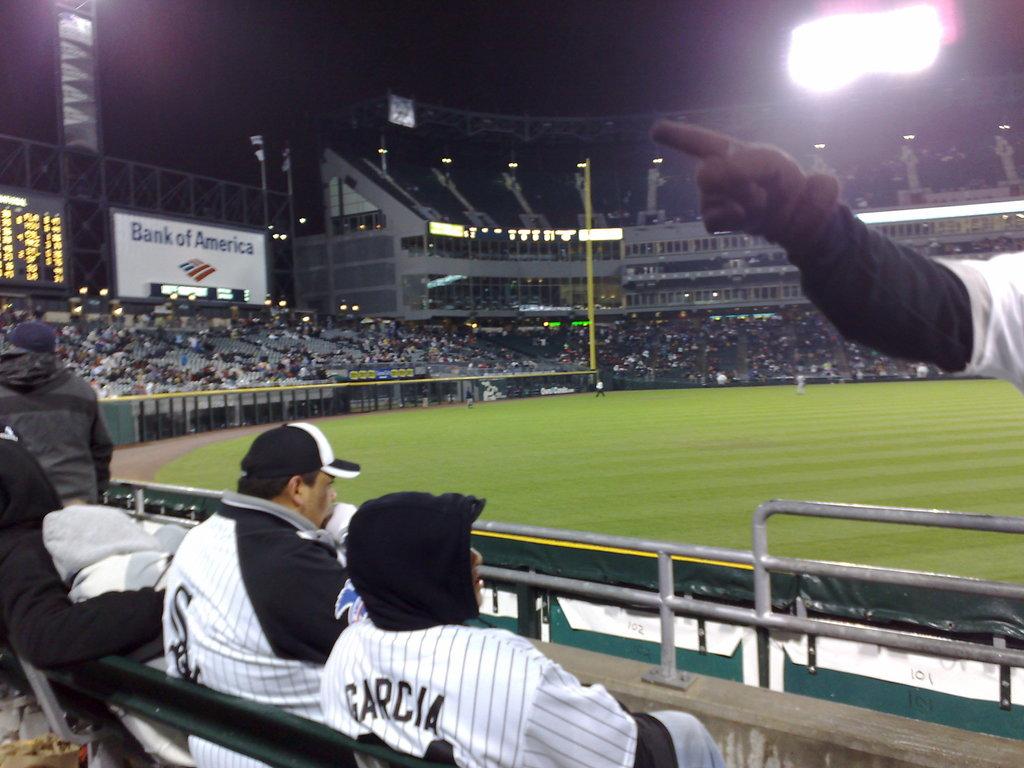What is the name on the back of the hooded man's shirt?
Make the answer very short. Garcia. 